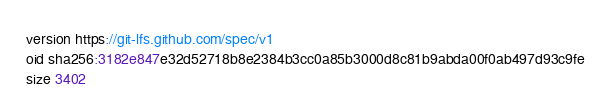<code> <loc_0><loc_0><loc_500><loc_500><_C_>version https://git-lfs.github.com/spec/v1
oid sha256:3182e847e32d52718b8e2384b3cc0a85b3000d8c81b9abda00f0ab497d93c9fe
size 3402
</code> 